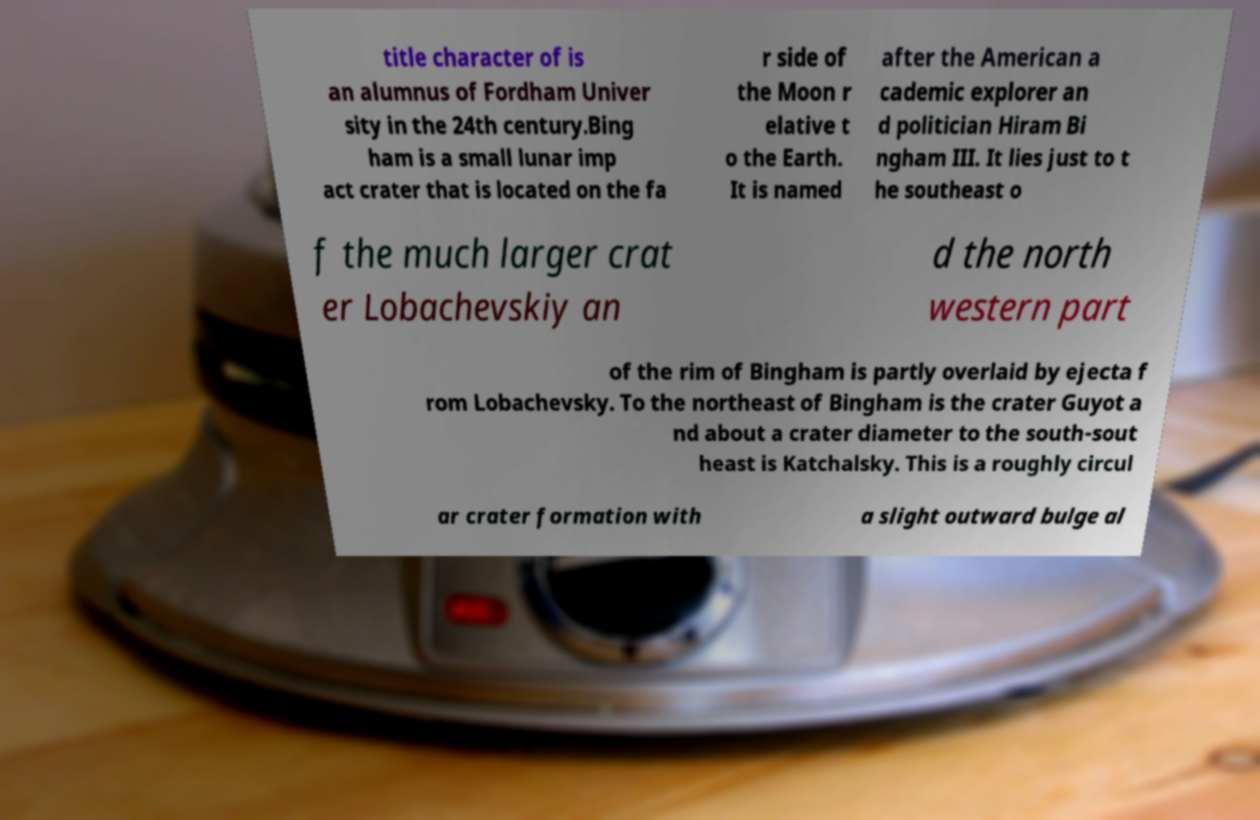Could you assist in decoding the text presented in this image and type it out clearly? title character of is an alumnus of Fordham Univer sity in the 24th century.Bing ham is a small lunar imp act crater that is located on the fa r side of the Moon r elative t o the Earth. It is named after the American a cademic explorer an d politician Hiram Bi ngham III. It lies just to t he southeast o f the much larger crat er Lobachevskiy an d the north western part of the rim of Bingham is partly overlaid by ejecta f rom Lobachevsky. To the northeast of Bingham is the crater Guyot a nd about a crater diameter to the south-sout heast is Katchalsky. This is a roughly circul ar crater formation with a slight outward bulge al 